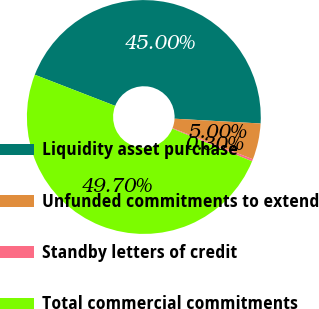<chart> <loc_0><loc_0><loc_500><loc_500><pie_chart><fcel>Liquidity asset purchase<fcel>Unfunded commitments to extend<fcel>Standby letters of credit<fcel>Total commercial commitments<nl><fcel>45.0%<fcel>5.0%<fcel>0.3%<fcel>49.7%<nl></chart> 